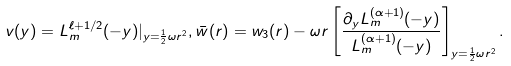<formula> <loc_0><loc_0><loc_500><loc_500>v ( y ) = L _ { m } ^ { \ell + 1 / 2 } ( - y ) | _ { y = \frac { 1 } { 2 } \omega r ^ { 2 } } , \bar { w } ( r ) = w _ { 3 } ( r ) - \omega r \left [ \frac { \partial _ { y } L _ { m } ^ { ( \alpha + 1 ) } ( - y ) } { L _ { m } ^ { ( \alpha + 1 ) } ( - y ) } \right ] _ { y = \frac { 1 } { 2 } \omega r ^ { 2 } } .</formula> 